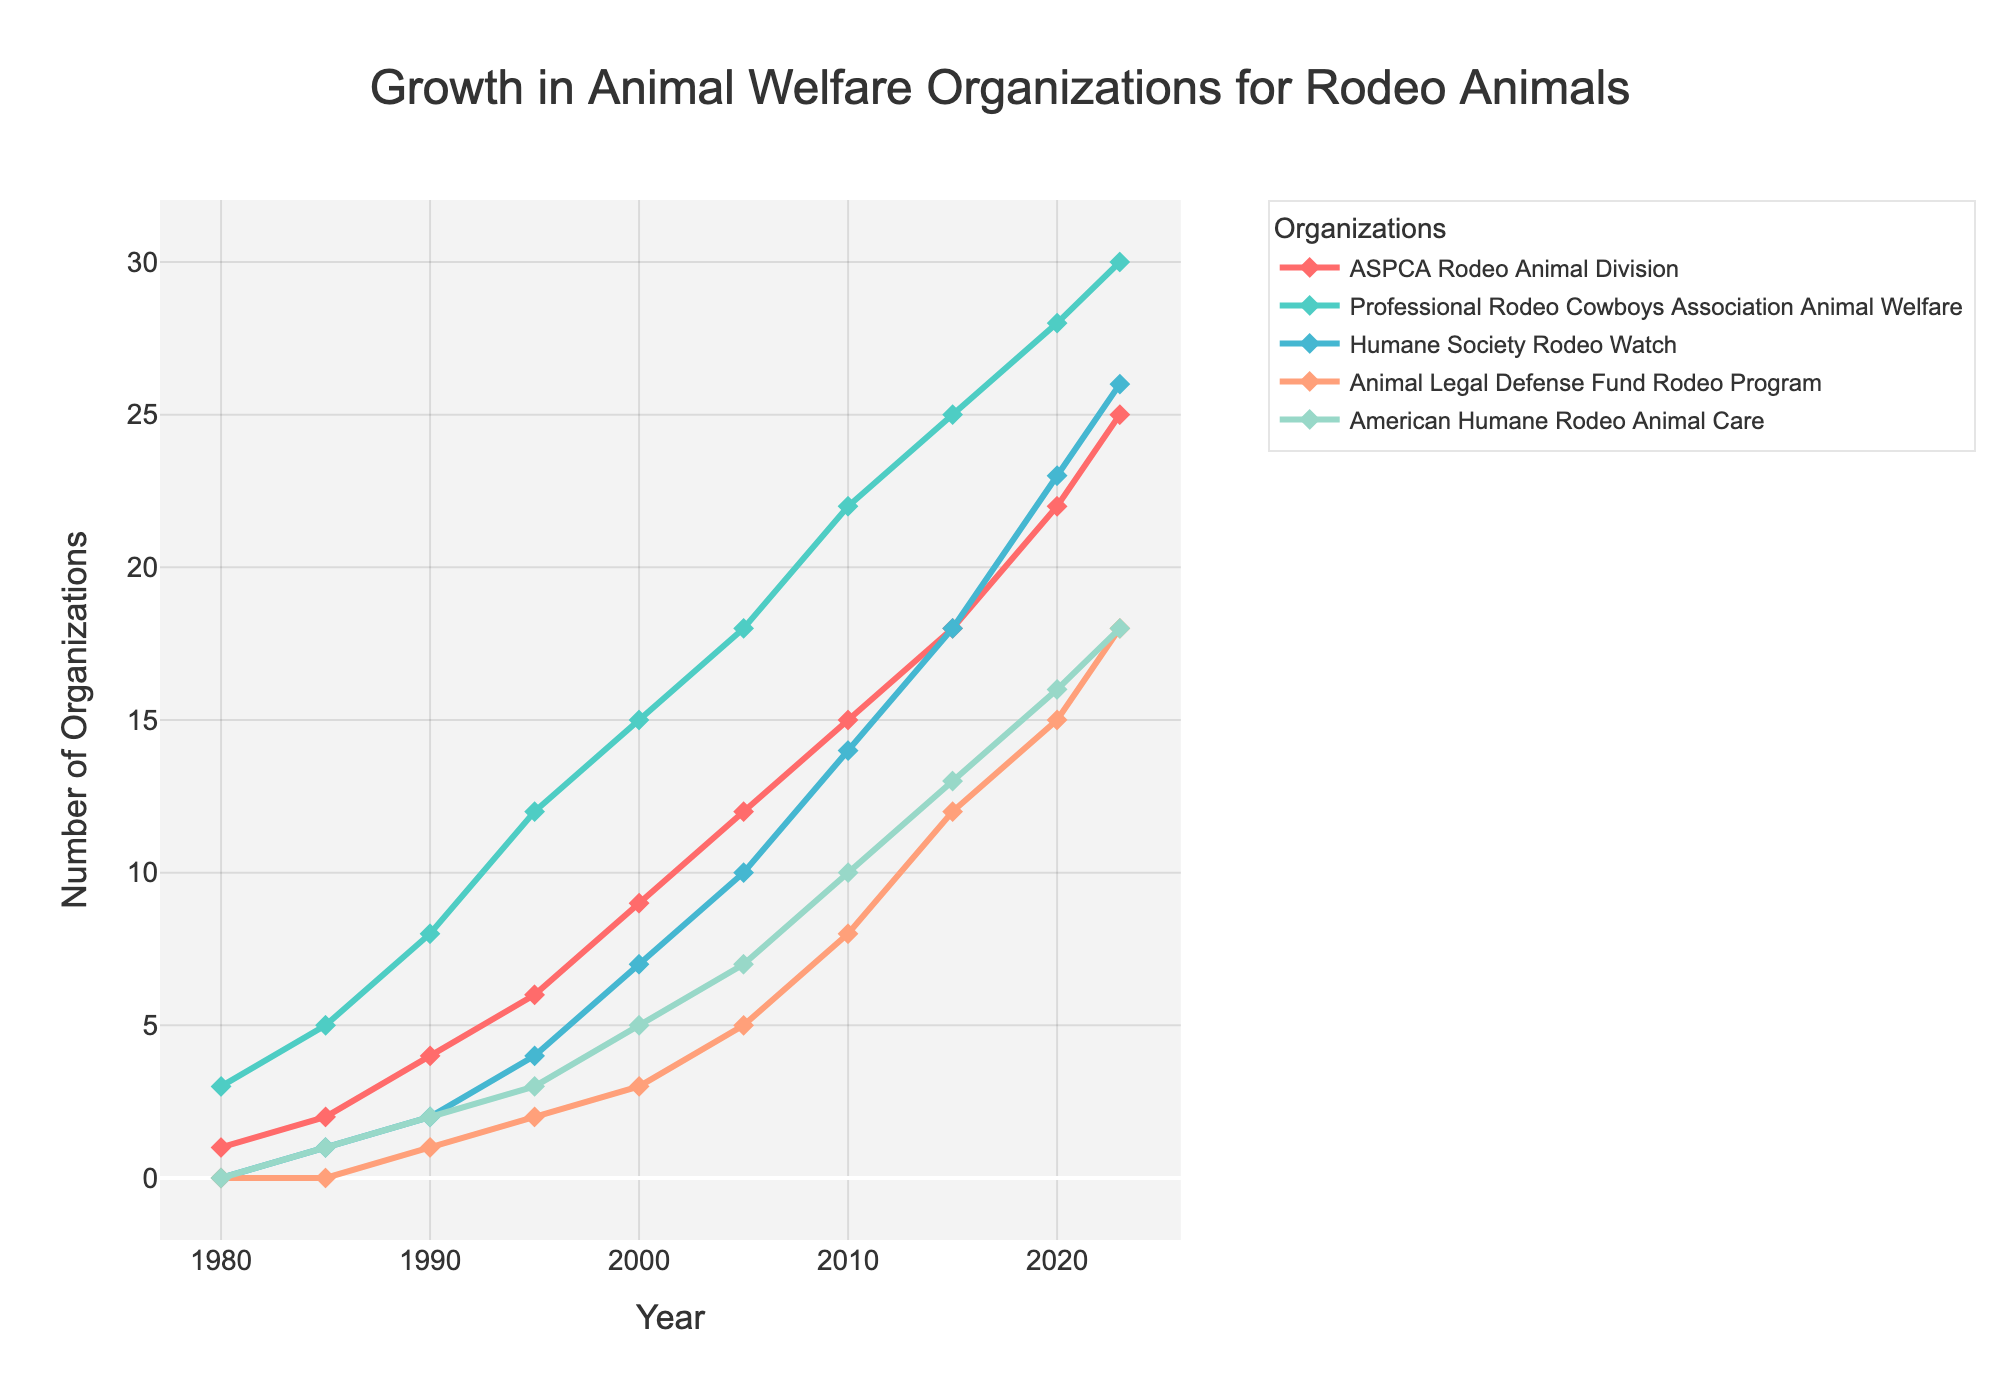What was the number of organizations for ASPCA Rodeo Animal Division in 2020? In 2020, the value for ASPCA Rodeo Animal Division is 22 as seen from the plot.
Answer: 22 Which organization had the highest count in 2023, and what is its value? In 2023, the Professional Rodeo Cowboys Association Animal Welfare had the highest count with a value of 30, as indicated by the tallest trace.
Answer: Professional Rodeo Cowboys Association Animal Welfare, 30 By how much did the number of organizations for the Humane Society Rodeo Watch increase between 2000 and 2010? In 2000, the Humane Society Rodeo Watch had 7 organizations. By 2010, this number increased to 14. The difference is 14 - 7.
Answer: 7 What is the combined number of organizations across all groups in 1995? Sum the values for all the organizations in 1995: 6 (ASPCA) + 12 (Professional Rodeo Cowboys Association) + 4 (Humane Society) + 2 (Animal Legal Defense Fund) + 3 (American Humane).
Answer: 27 Between 1980 and 2023, which organization showed the largest absolute growth in the number of welfare groups, and what was the magnitude of this growth? ASPCA Rodeo Animal Division started at 1 in 1980 and grew to 25 in 2023, giving an absolute growth of 24. Other organizations had less growth over the same period.
Answer: ASPCA Rodeo Animal Division, 24 During which period did the Professional Rodeo Cowboys Association Animal Welfare experience the largest increase in the number of organizations? By examining the chart, the steepest slope for the Professional Rodeo Cowboys Association Animal Welfare appears between 1990 and 1995, where the count increased from 8 to 12.
Answer: 1990-1995 What is the average number of organizations for American Humane Rodeo Animal Care from 1980 to 2023? The organization values are: 0, 1, 2, 3, 5, 7, 10, 13, 16, and 18. Sum these values: 75, and divide by the count of years: 10.
Answer: 7.5 Which two organizations had the same number of groups in any given year, and in which year was this observed? ASPCA Rodeo Animal Division and Animal Legal Defense Fund Rodeo Program both had 18 groups in 2023.
Answer: 2023 